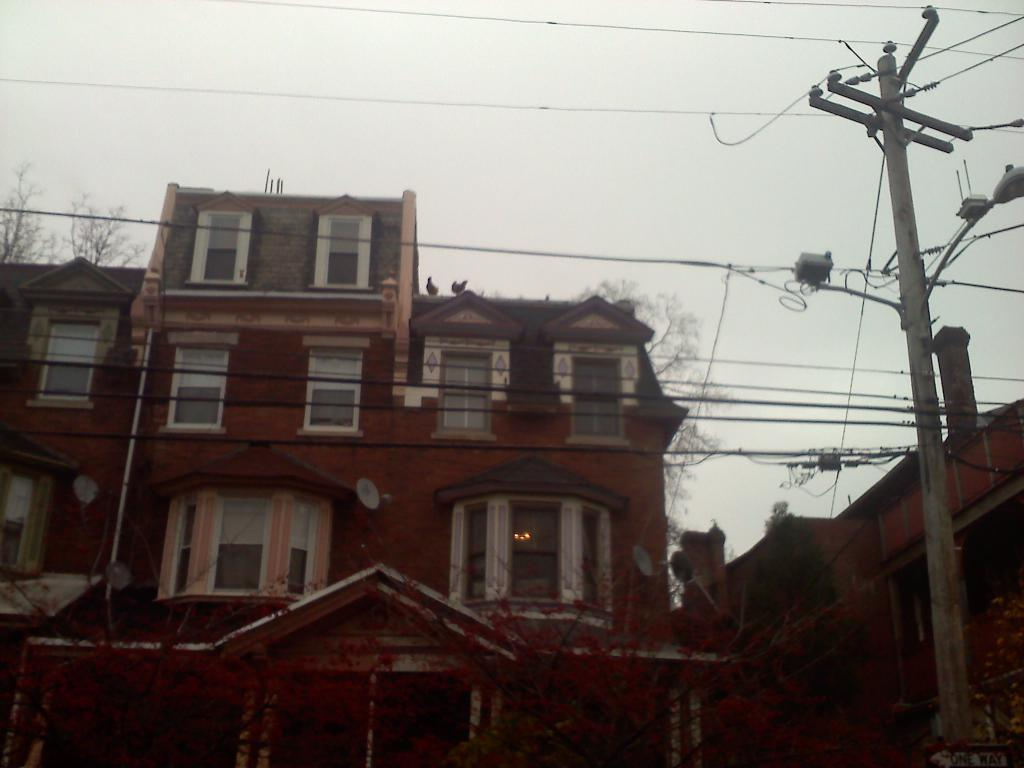What is the main structure in the image? There is a pole in the image. What else can be seen in the image besides the pole? There are wires, trees, buildings with windows, and some objects in the image. Can you describe the buildings in the image? The buildings have windows. What is visible in the background of the image? The sky is visible in the background of the image. What type of ornament is hanging from the pole in the image? There is no ornament hanging from the pole in the image; only wires and trees are visible. 